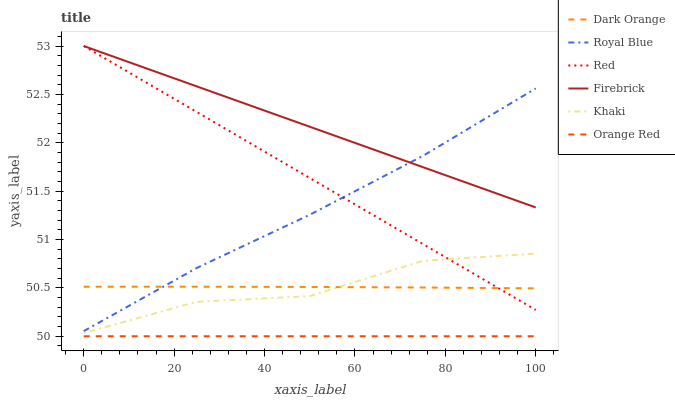Does Orange Red have the minimum area under the curve?
Answer yes or no. Yes. Does Firebrick have the maximum area under the curve?
Answer yes or no. Yes. Does Khaki have the minimum area under the curve?
Answer yes or no. No. Does Khaki have the maximum area under the curve?
Answer yes or no. No. Is Firebrick the smoothest?
Answer yes or no. Yes. Is Khaki the roughest?
Answer yes or no. Yes. Is Khaki the smoothest?
Answer yes or no. No. Is Firebrick the roughest?
Answer yes or no. No. Does Orange Red have the lowest value?
Answer yes or no. Yes. Does Khaki have the lowest value?
Answer yes or no. No. Does Red have the highest value?
Answer yes or no. Yes. Does Khaki have the highest value?
Answer yes or no. No. Is Khaki less than Royal Blue?
Answer yes or no. Yes. Is Royal Blue greater than Orange Red?
Answer yes or no. Yes. Does Red intersect Dark Orange?
Answer yes or no. Yes. Is Red less than Dark Orange?
Answer yes or no. No. Is Red greater than Dark Orange?
Answer yes or no. No. Does Khaki intersect Royal Blue?
Answer yes or no. No. 